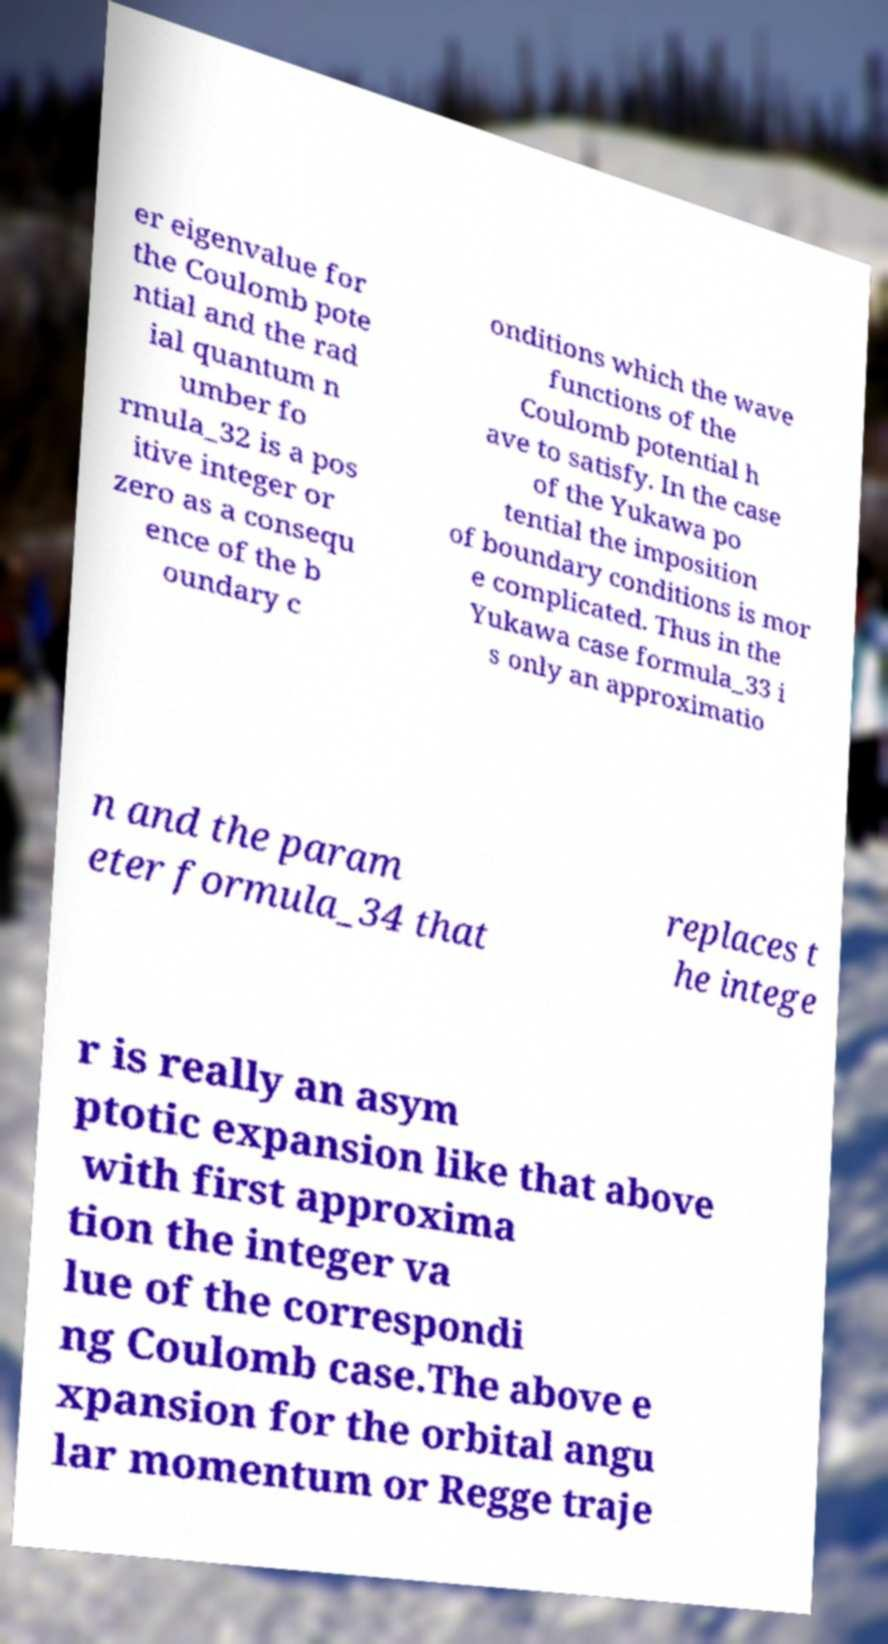What messages or text are displayed in this image? I need them in a readable, typed format. er eigenvalue for the Coulomb pote ntial and the rad ial quantum n umber fo rmula_32 is a pos itive integer or zero as a consequ ence of the b oundary c onditions which the wave functions of the Coulomb potential h ave to satisfy. In the case of the Yukawa po tential the imposition of boundary conditions is mor e complicated. Thus in the Yukawa case formula_33 i s only an approximatio n and the param eter formula_34 that replaces t he intege r is really an asym ptotic expansion like that above with first approxima tion the integer va lue of the correspondi ng Coulomb case.The above e xpansion for the orbital angu lar momentum or Regge traje 